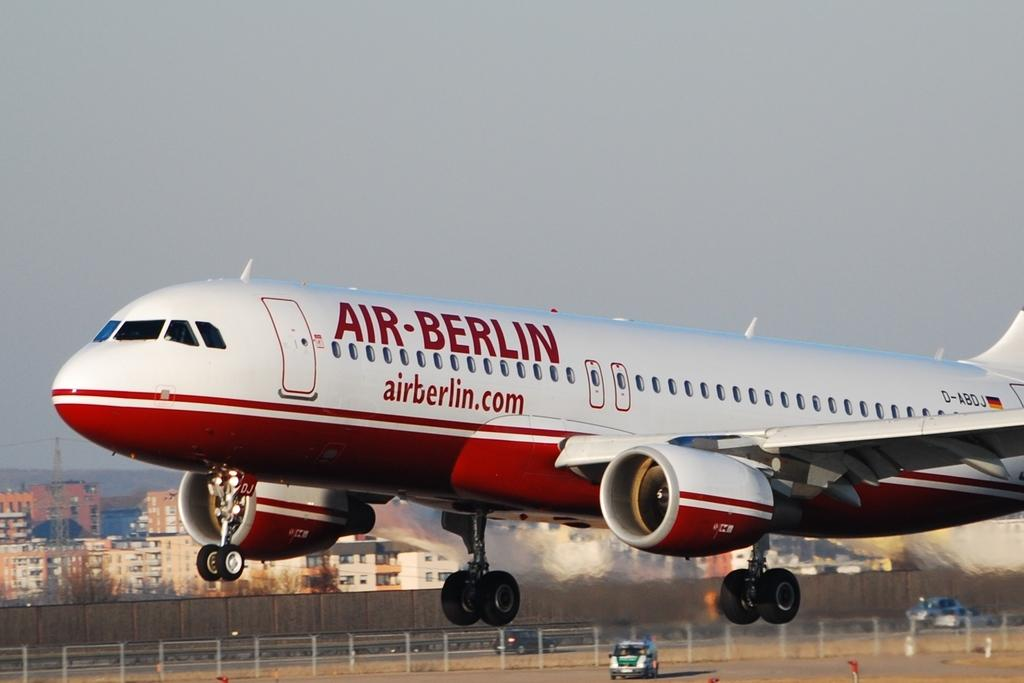<image>
Offer a succinct explanation of the picture presented. A white and red Air Berlin Airplane at the early stage of take off. 